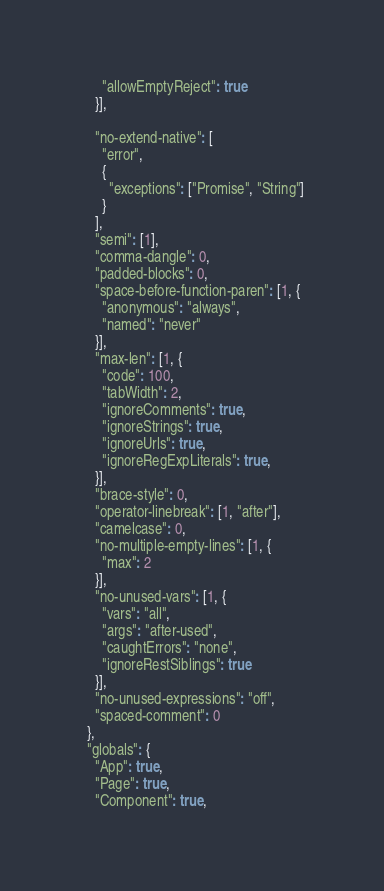<code> <loc_0><loc_0><loc_500><loc_500><_JavaScript_>      "allowEmptyReject": true
    }],

    "no-extend-native": [
      "error",
      {
        "exceptions": ["Promise", "String"]
      }
    ],
    "semi": [1],
    "comma-dangle": 0,
    "padded-blocks": 0,
    "space-before-function-paren": [1, {
      "anonymous": "always",
      "named": "never"
    }],
    "max-len": [1, {
      "code": 100,
      "tabWidth": 2,
      "ignoreComments": true,
      "ignoreStrings": true,
      "ignoreUrls": true,
      "ignoreRegExpLiterals": true,
    }],
    "brace-style": 0,
    "operator-linebreak": [1, "after"],
    "camelcase": 0,
    "no-multiple-empty-lines": [1, {
      "max": 2
    }],
    "no-unused-vars": [1, {
      "vars": "all",
      "args": "after-used",
      "caughtErrors": "none",
      "ignoreRestSiblings": true
    }],
    "no-unused-expressions": "off",
    "spaced-comment": 0
  },
  "globals": {
    "App": true,
    "Page": true,
    "Component": true,</code> 